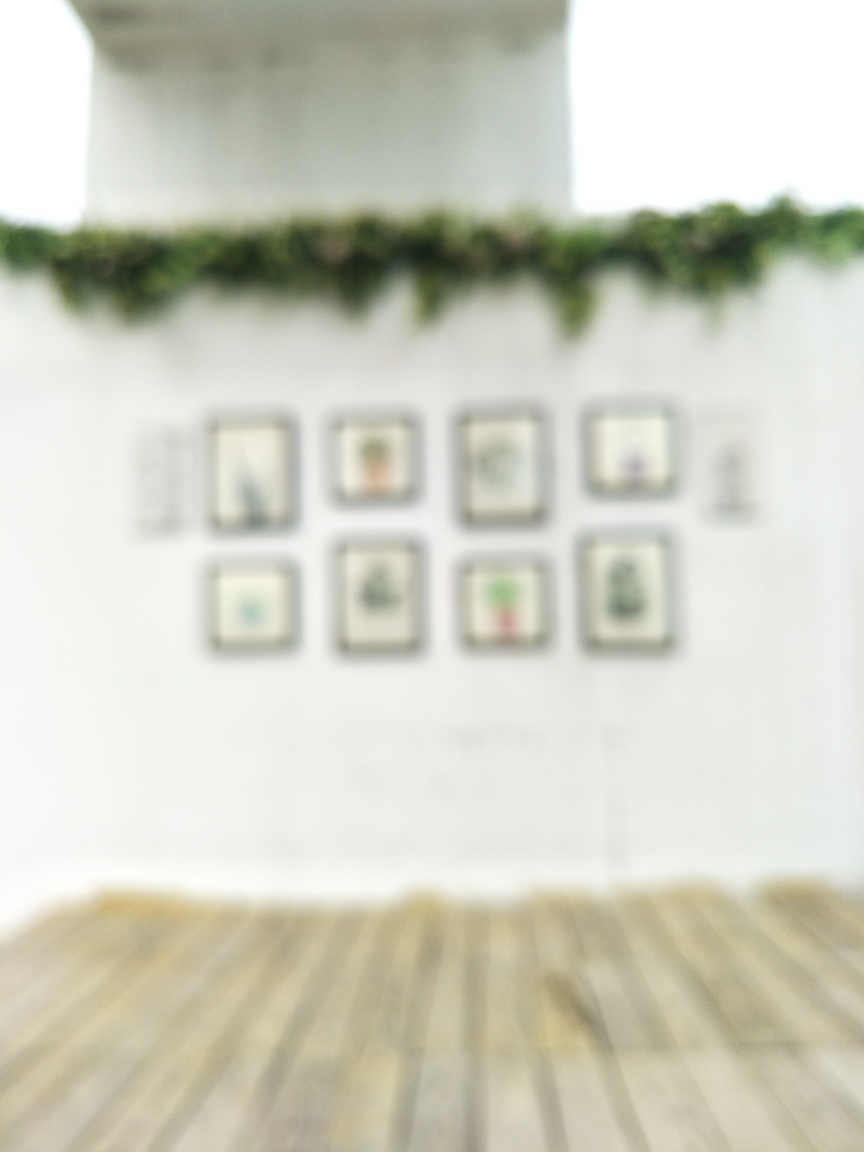Does the image have poor quality? Yes, the image is blurry which makes the details hard to distinguish, affecting the visual quality significantly. 